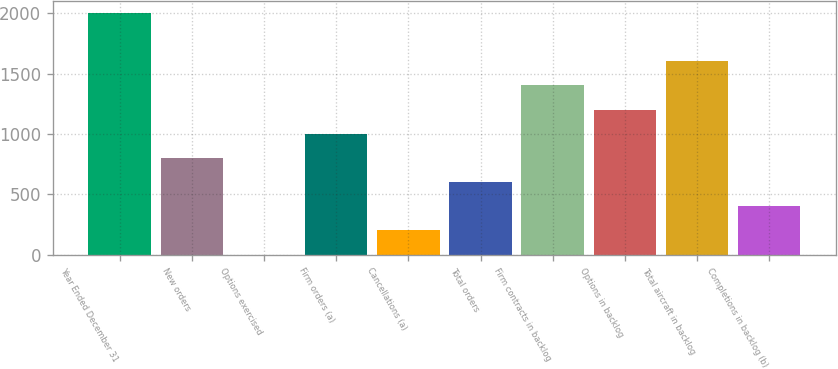Convert chart to OTSL. <chart><loc_0><loc_0><loc_500><loc_500><bar_chart><fcel>Year Ended December 31<fcel>New orders<fcel>Options exercised<fcel>Firm orders (a)<fcel>Cancellations (a)<fcel>Total orders<fcel>Firm contracts in backlog<fcel>Options in backlog<fcel>Total aircraft in backlog<fcel>Completions in backlog (b)<nl><fcel>2004<fcel>802.2<fcel>1<fcel>1002.5<fcel>201.3<fcel>601.9<fcel>1403.1<fcel>1202.8<fcel>1603.4<fcel>401.6<nl></chart> 